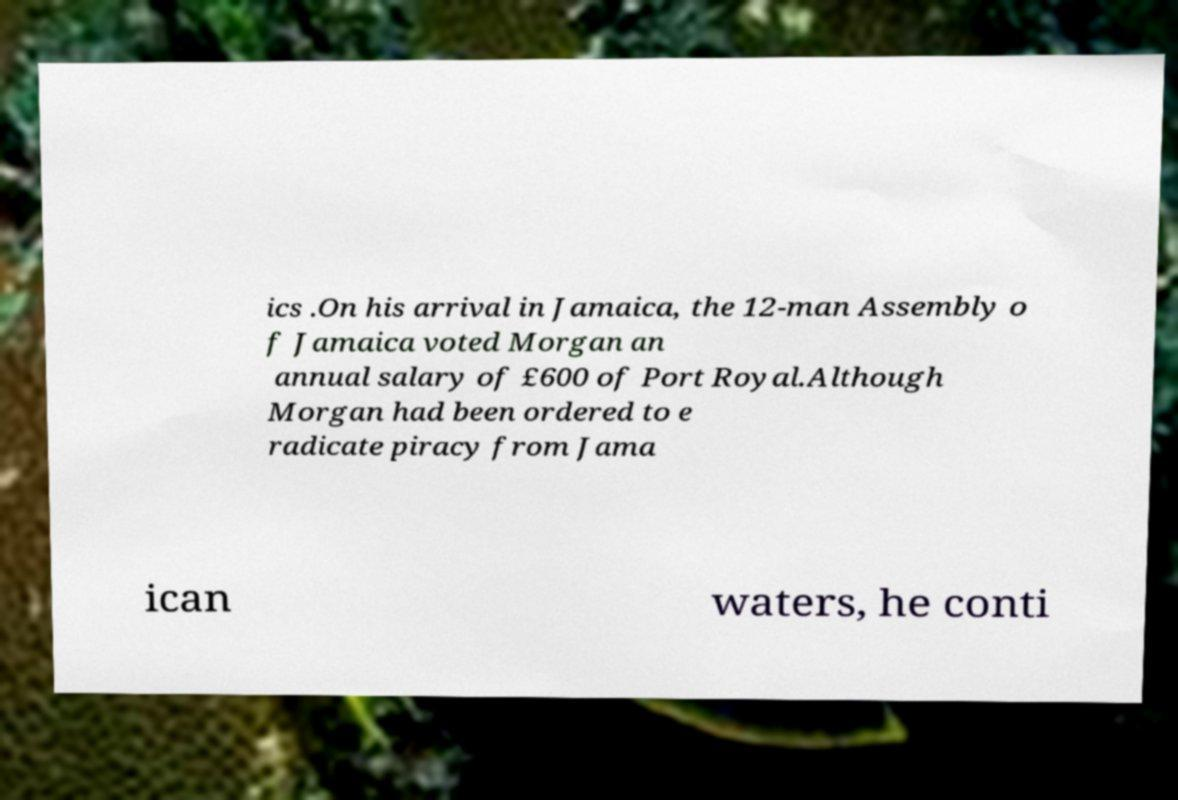Could you extract and type out the text from this image? ics .On his arrival in Jamaica, the 12-man Assembly o f Jamaica voted Morgan an annual salary of £600 of Port Royal.Although Morgan had been ordered to e radicate piracy from Jama ican waters, he conti 